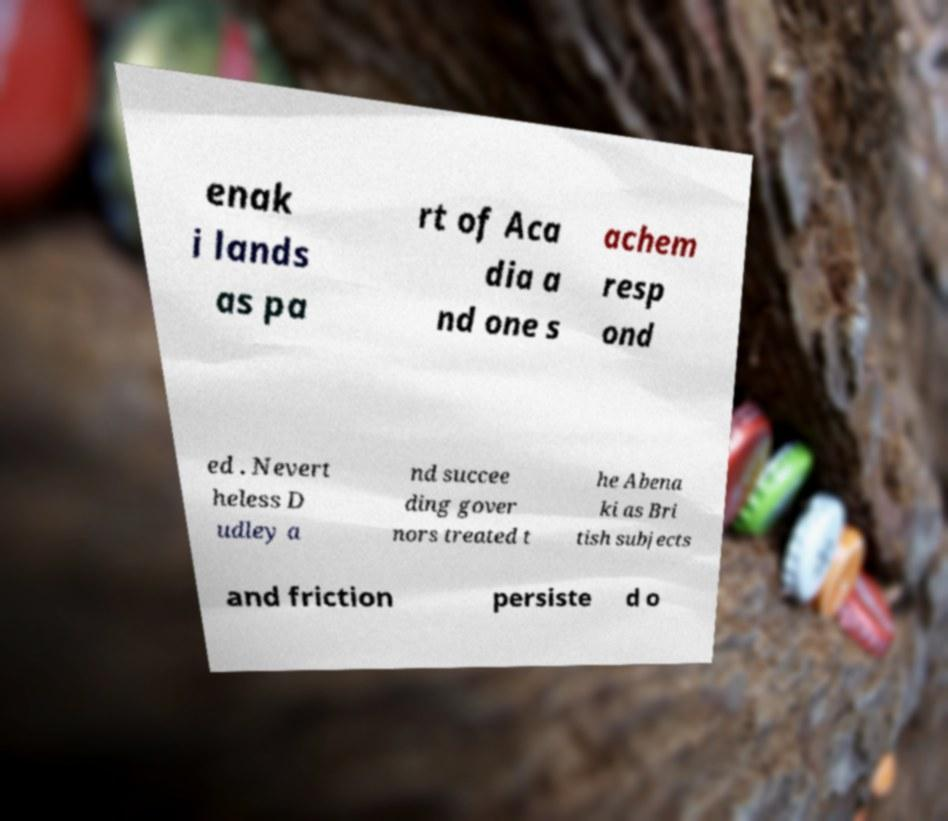There's text embedded in this image that I need extracted. Can you transcribe it verbatim? enak i lands as pa rt of Aca dia a nd one s achem resp ond ed . Nevert heless D udley a nd succee ding gover nors treated t he Abena ki as Bri tish subjects and friction persiste d o 